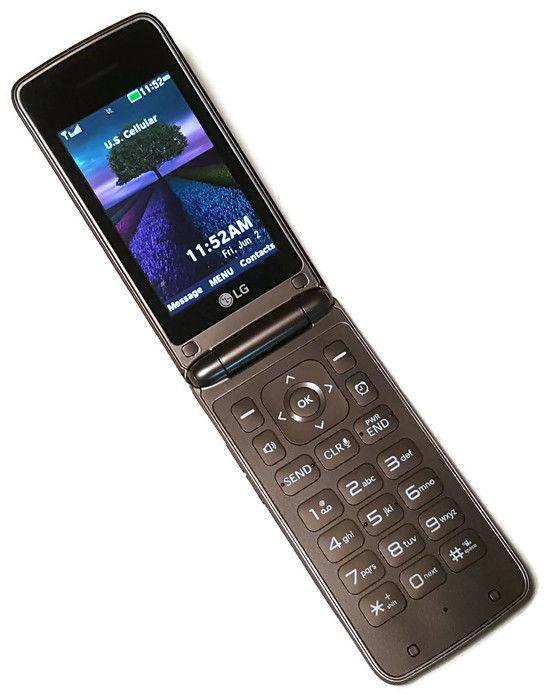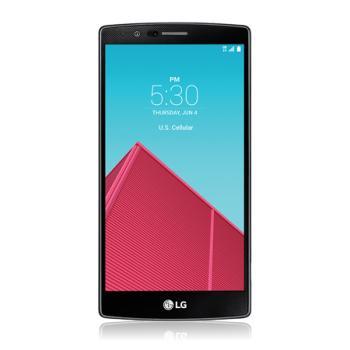The first image is the image on the left, the second image is the image on the right. Evaluate the accuracy of this statement regarding the images: "One of the phones has keys that slide out from under the screen.". Is it true? Answer yes or no. No. The first image is the image on the left, the second image is the image on the right. Assess this claim about the two images: "There is one modern touchscreen smartphone and one older cell phone with buttons.". Correct or not? Answer yes or no. Yes. 